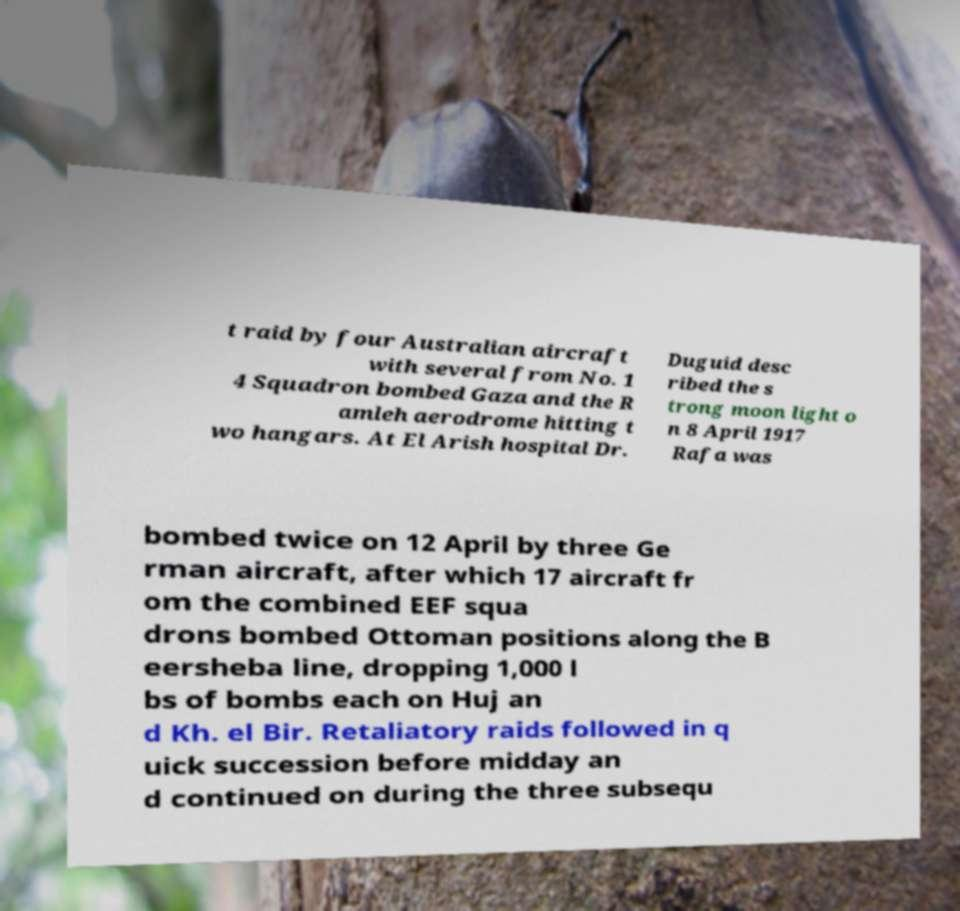For documentation purposes, I need the text within this image transcribed. Could you provide that? t raid by four Australian aircraft with several from No. 1 4 Squadron bombed Gaza and the R amleh aerodrome hitting t wo hangars. At El Arish hospital Dr. Duguid desc ribed the s trong moon light o n 8 April 1917 Rafa was bombed twice on 12 April by three Ge rman aircraft, after which 17 aircraft fr om the combined EEF squa drons bombed Ottoman positions along the B eersheba line, dropping 1,000 l bs of bombs each on Huj an d Kh. el Bir. Retaliatory raids followed in q uick succession before midday an d continued on during the three subsequ 